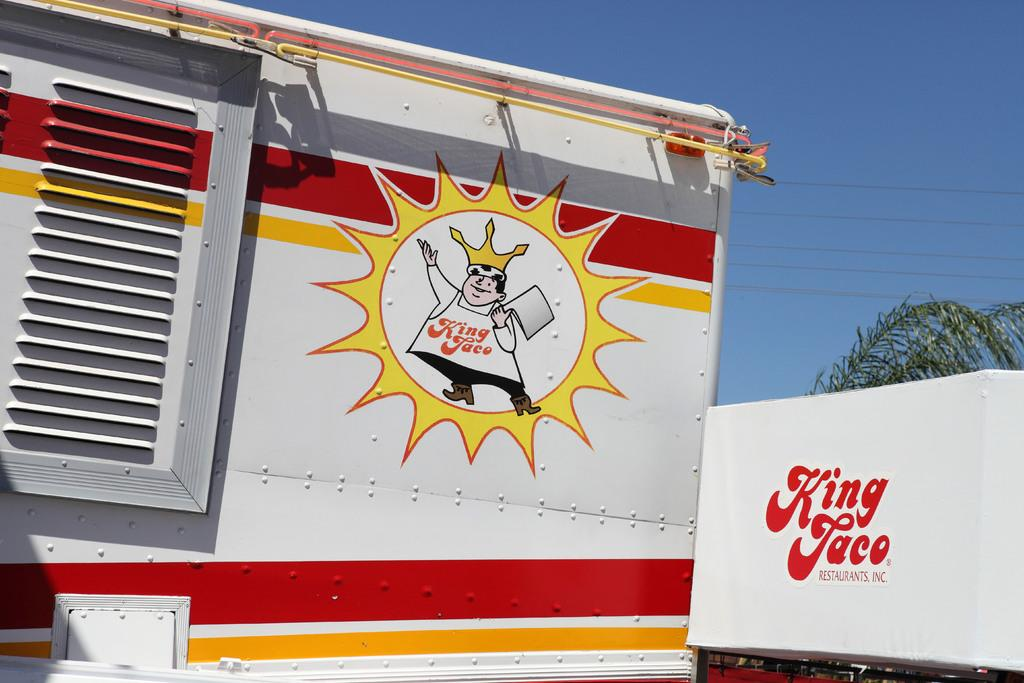What type of vehicle is in the image? There is a multi-colored vehicle in the image. What is the white object in the image? There is a white color board in the image. What can be seen in the background of the image? There is a plant in the background of the image. Where is the nest of the bird in the image? There is no bird or nest present in the image. 